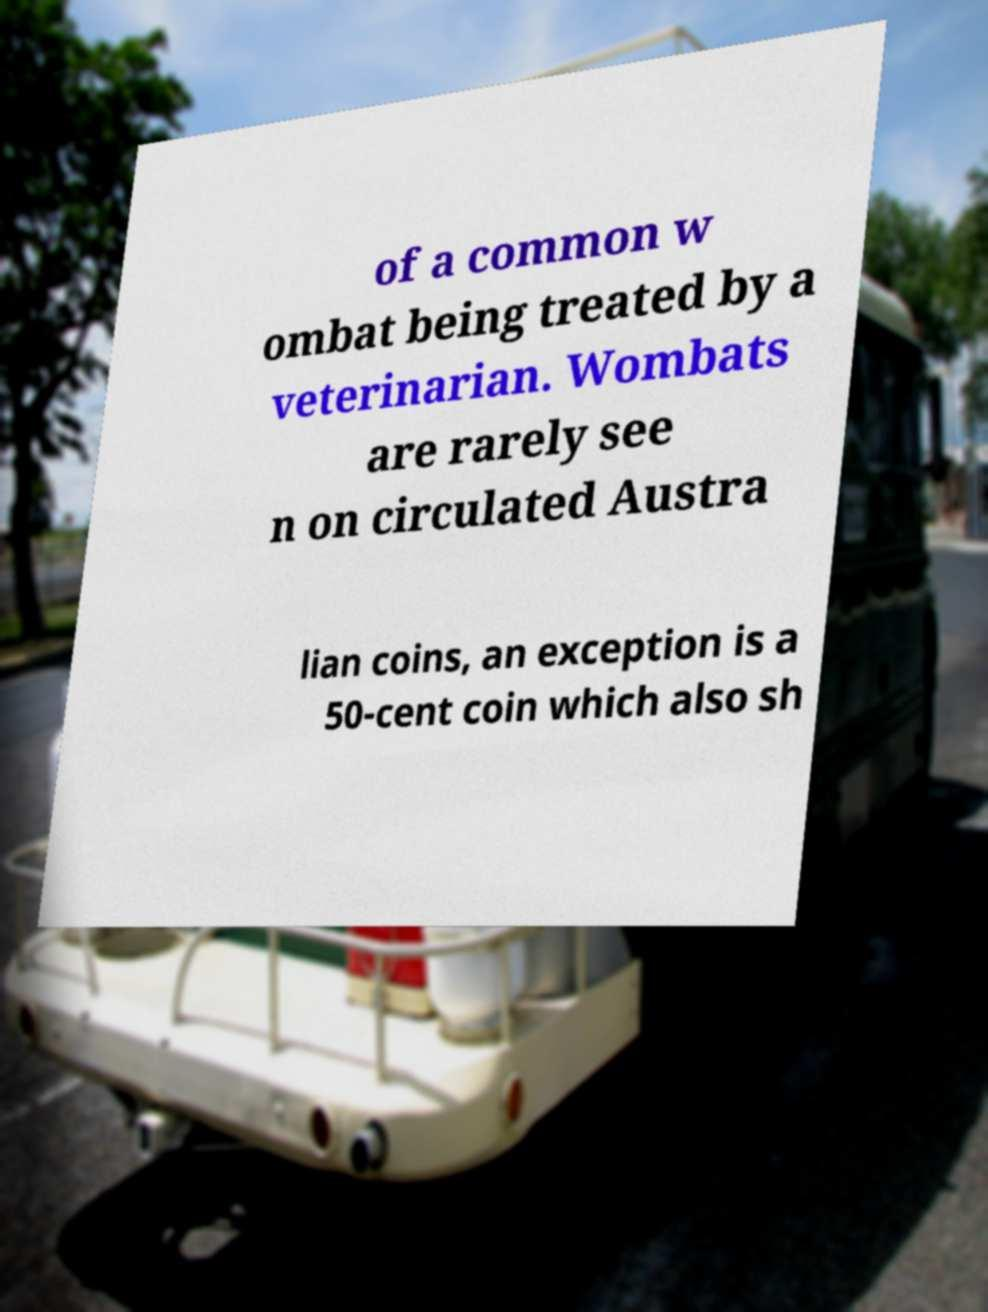Can you read and provide the text displayed in the image?This photo seems to have some interesting text. Can you extract and type it out for me? of a common w ombat being treated by a veterinarian. Wombats are rarely see n on circulated Austra lian coins, an exception is a 50-cent coin which also sh 